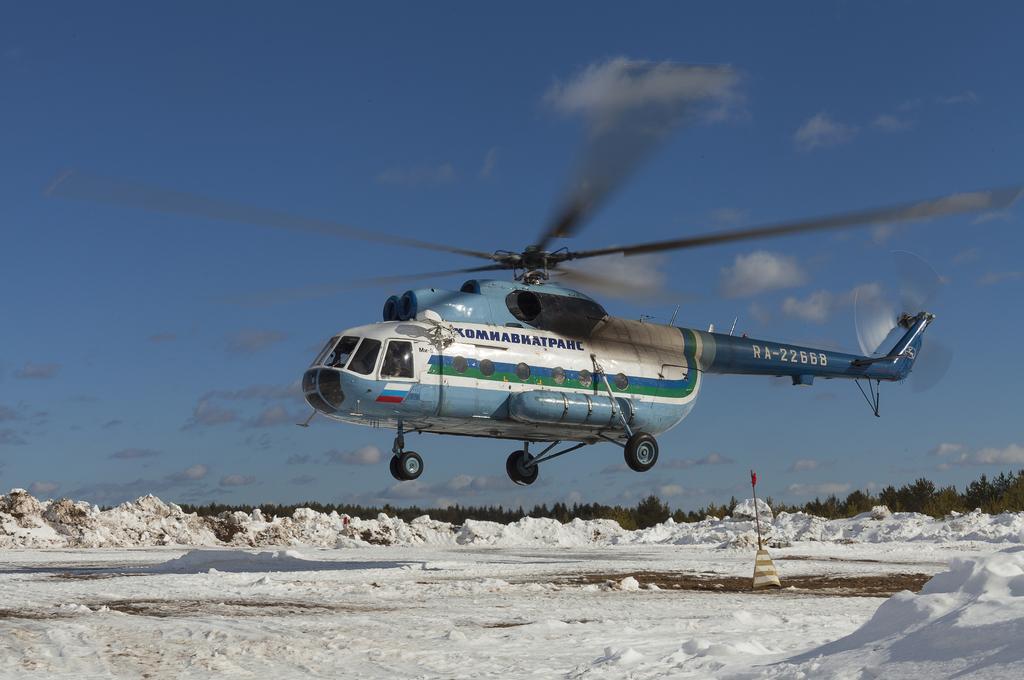Describe this image in one or two sentences. In this image I can see an aircraft and the aircraft is in white and blue color and I can see the snow in white color, background I can see trees in green color and the sky is in blue and white color. 